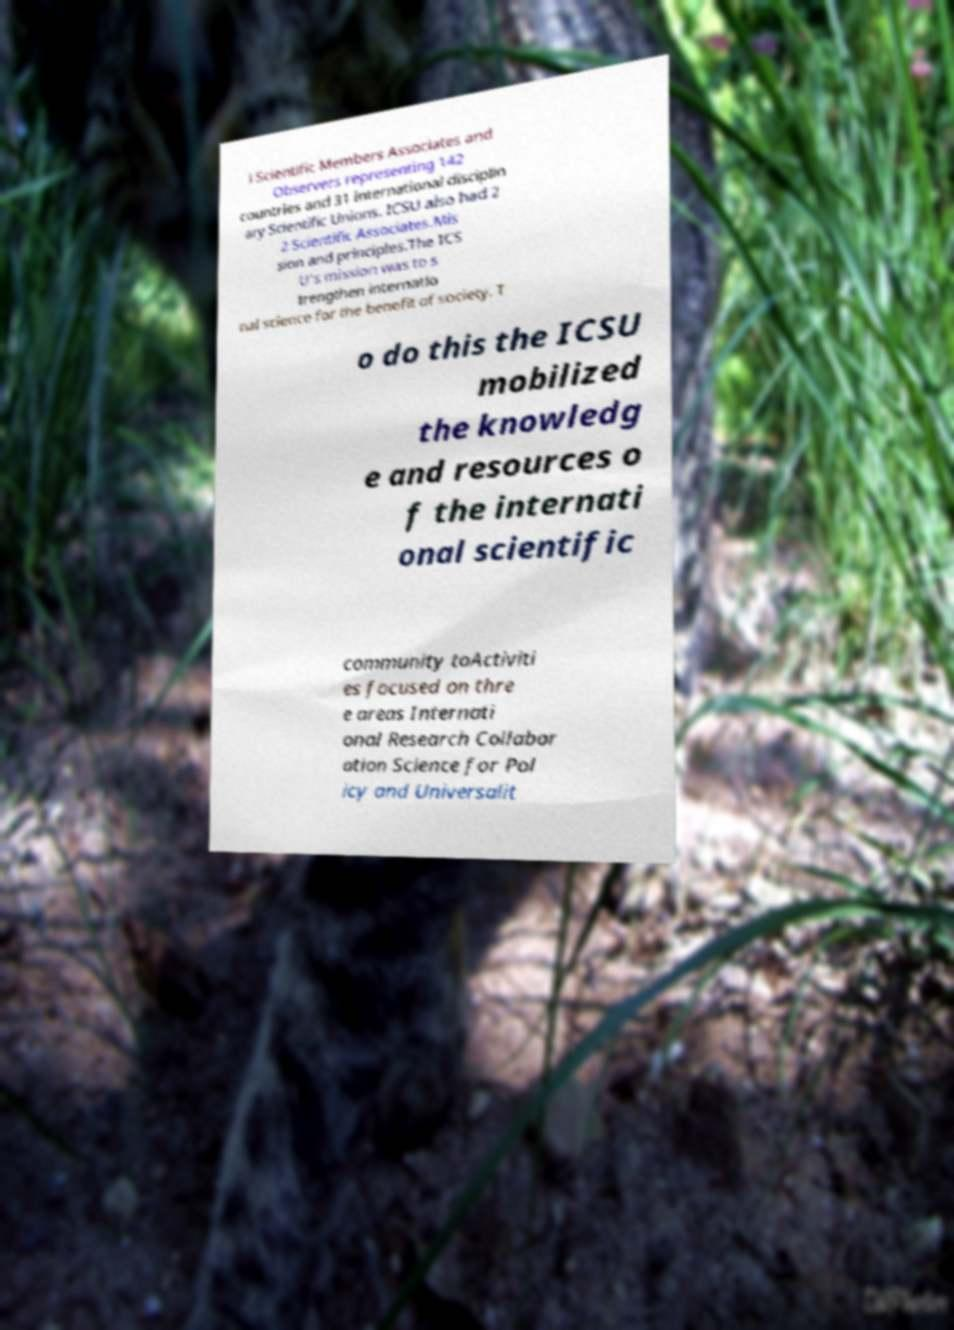Can you read and provide the text displayed in the image?This photo seems to have some interesting text. Can you extract and type it out for me? l Scientific Members Associates and Observers representing 142 countries and 31 international disciplin ary Scientific Unions. ICSU also had 2 2 Scientific Associates.Mis sion and principles.The ICS U's mission was to s trengthen internatio nal science for the benefit of society. T o do this the ICSU mobilized the knowledg e and resources o f the internati onal scientific community toActiviti es focused on thre e areas Internati onal Research Collabor ation Science for Pol icy and Universalit 